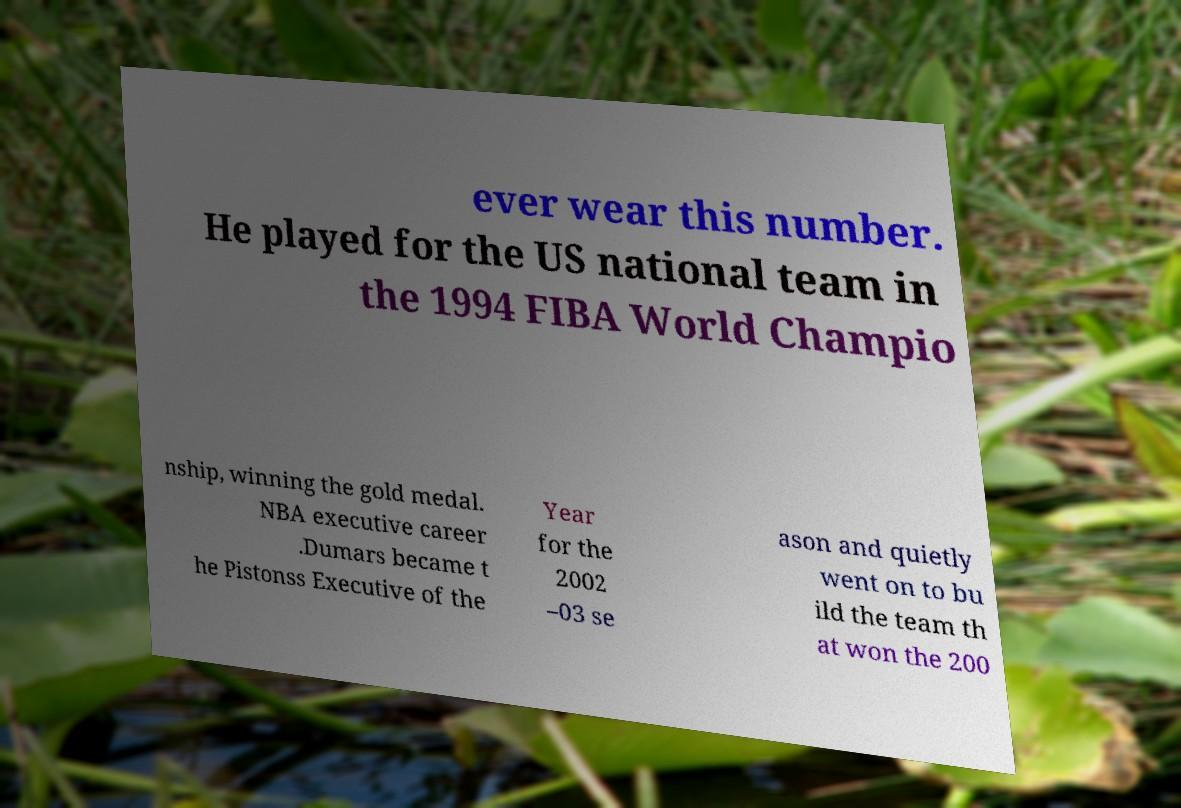Can you read and provide the text displayed in the image?This photo seems to have some interesting text. Can you extract and type it out for me? ever wear this number. He played for the US national team in the 1994 FIBA World Champio nship, winning the gold medal. NBA executive career .Dumars became t he Pistonss Executive of the Year for the 2002 –03 se ason and quietly went on to bu ild the team th at won the 200 